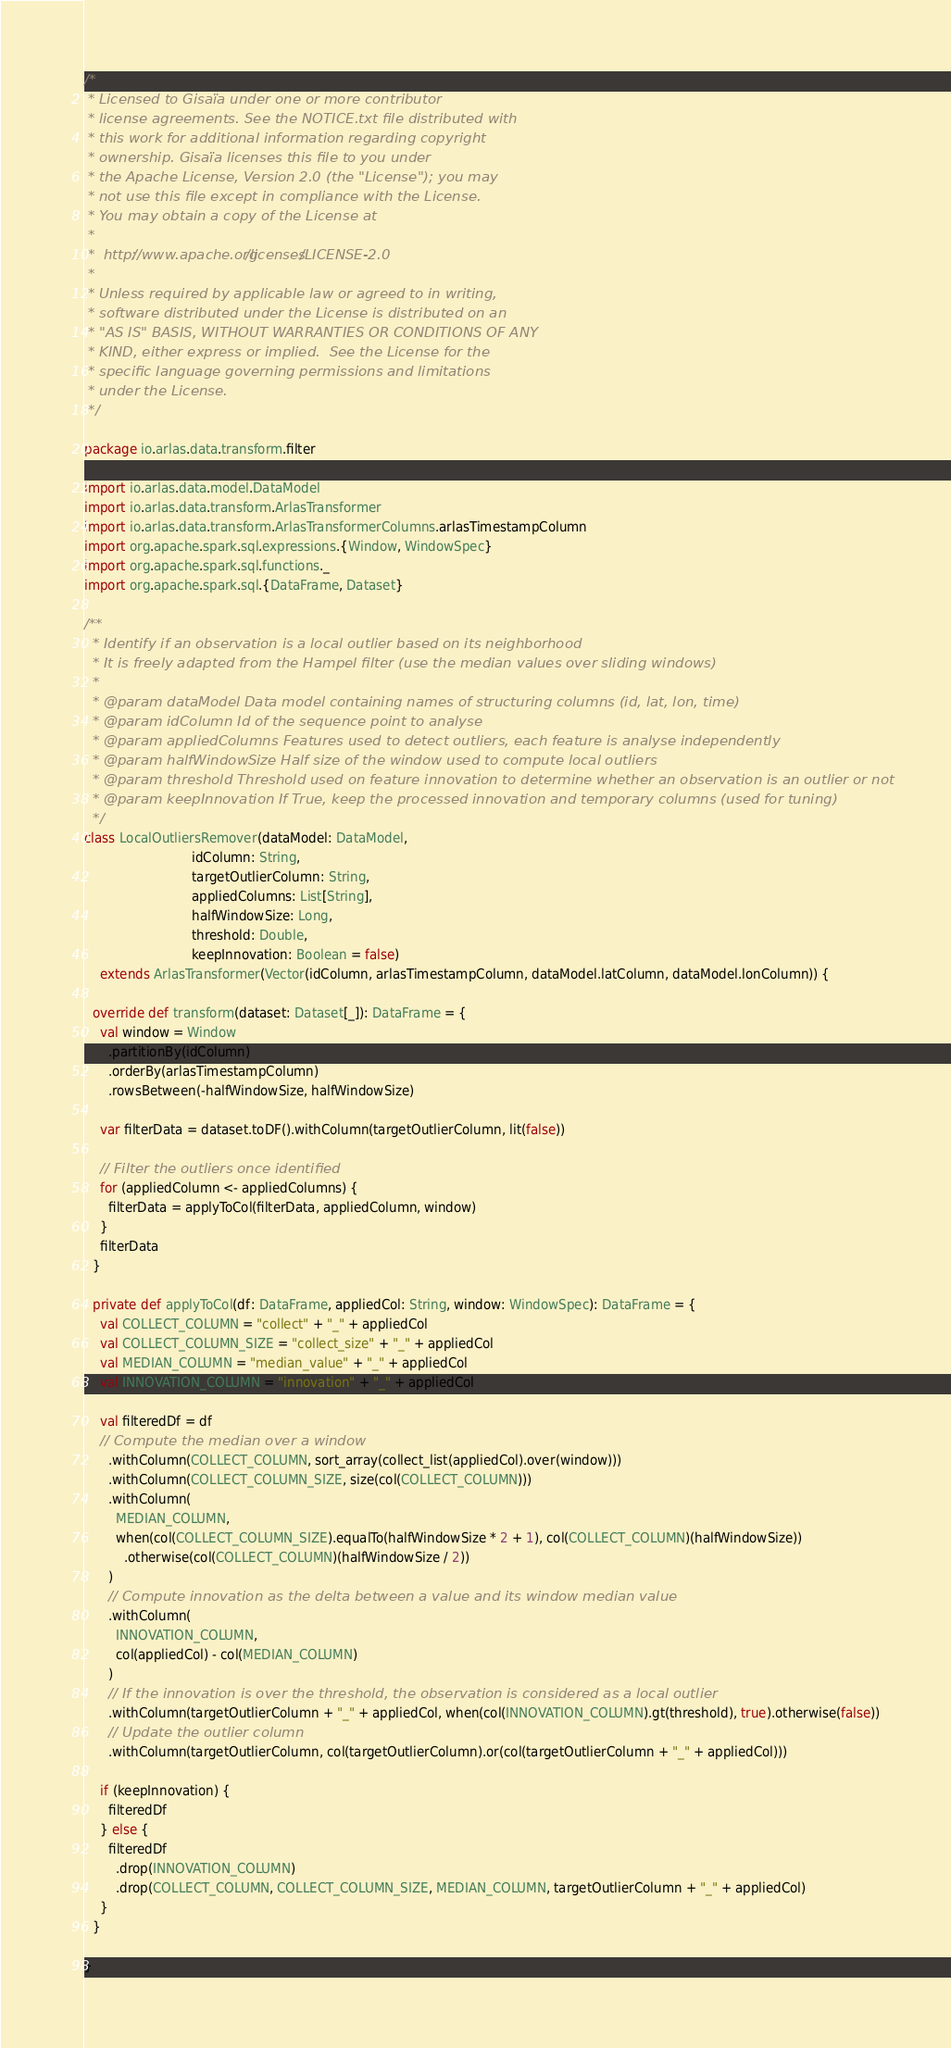<code> <loc_0><loc_0><loc_500><loc_500><_Scala_>/*
 * Licensed to Gisaïa under one or more contributor
 * license agreements. See the NOTICE.txt file distributed with
 * this work for additional information regarding copyright
 * ownership. Gisaïa licenses this file to you under
 * the Apache License, Version 2.0 (the "License"); you may
 * not use this file except in compliance with the License.
 * You may obtain a copy of the License at
 *
 *  http://www.apache.org/licenses/LICENSE-2.0
 *
 * Unless required by applicable law or agreed to in writing,
 * software distributed under the License is distributed on an
 * "AS IS" BASIS, WITHOUT WARRANTIES OR CONDITIONS OF ANY
 * KIND, either express or implied.  See the License for the
 * specific language governing permissions and limitations
 * under the License.
 */

package io.arlas.data.transform.filter

import io.arlas.data.model.DataModel
import io.arlas.data.transform.ArlasTransformer
import io.arlas.data.transform.ArlasTransformerColumns.arlasTimestampColumn
import org.apache.spark.sql.expressions.{Window, WindowSpec}
import org.apache.spark.sql.functions._
import org.apache.spark.sql.{DataFrame, Dataset}

/**
  * Identify if an observation is a local outlier based on its neighborhood
  * It is freely adapted from the Hampel filter (use the median values over sliding windows)
  *
  * @param dataModel Data model containing names of structuring columns (id, lat, lon, time)
  * @param idColumn Id of the sequence point to analyse
  * @param appliedColumns Features used to detect outliers, each feature is analyse independently
  * @param halfWindowSize Half size of the window used to compute local outliers
  * @param threshold Threshold used on feature innovation to determine whether an observation is an outlier or not
  * @param keepInnovation If True, keep the processed innovation and temporary columns (used for tuning)
  */
class LocalOutliersRemover(dataModel: DataModel,
                           idColumn: String,
                           targetOutlierColumn: String,
                           appliedColumns: List[String],
                           halfWindowSize: Long,
                           threshold: Double,
                           keepInnovation: Boolean = false)
    extends ArlasTransformer(Vector(idColumn, arlasTimestampColumn, dataModel.latColumn, dataModel.lonColumn)) {

  override def transform(dataset: Dataset[_]): DataFrame = {
    val window = Window
      .partitionBy(idColumn)
      .orderBy(arlasTimestampColumn)
      .rowsBetween(-halfWindowSize, halfWindowSize)

    var filterData = dataset.toDF().withColumn(targetOutlierColumn, lit(false))

    // Filter the outliers once identified
    for (appliedColumn <- appliedColumns) {
      filterData = applyToCol(filterData, appliedColumn, window)
    }
    filterData
  }

  private def applyToCol(df: DataFrame, appliedCol: String, window: WindowSpec): DataFrame = {
    val COLLECT_COLUMN = "collect" + "_" + appliedCol
    val COLLECT_COLUMN_SIZE = "collect_size" + "_" + appliedCol
    val MEDIAN_COLUMN = "median_value" + "_" + appliedCol
    val INNOVATION_COLUMN = "innovation" + "_" + appliedCol

    val filteredDf = df
    // Compute the median over a window
      .withColumn(COLLECT_COLUMN, sort_array(collect_list(appliedCol).over(window)))
      .withColumn(COLLECT_COLUMN_SIZE, size(col(COLLECT_COLUMN)))
      .withColumn(
        MEDIAN_COLUMN,
        when(col(COLLECT_COLUMN_SIZE).equalTo(halfWindowSize * 2 + 1), col(COLLECT_COLUMN)(halfWindowSize))
          .otherwise(col(COLLECT_COLUMN)(halfWindowSize / 2))
      )
      // Compute innovation as the delta between a value and its window median value
      .withColumn(
        INNOVATION_COLUMN,
        col(appliedCol) - col(MEDIAN_COLUMN)
      )
      // If the innovation is over the threshold, the observation is considered as a local outlier
      .withColumn(targetOutlierColumn + "_" + appliedCol, when(col(INNOVATION_COLUMN).gt(threshold), true).otherwise(false))
      // Update the outlier column
      .withColumn(targetOutlierColumn, col(targetOutlierColumn).or(col(targetOutlierColumn + "_" + appliedCol)))

    if (keepInnovation) {
      filteredDf
    } else {
      filteredDf
        .drop(INNOVATION_COLUMN)
        .drop(COLLECT_COLUMN, COLLECT_COLUMN_SIZE, MEDIAN_COLUMN, targetOutlierColumn + "_" + appliedCol)
    }
  }

}
</code> 